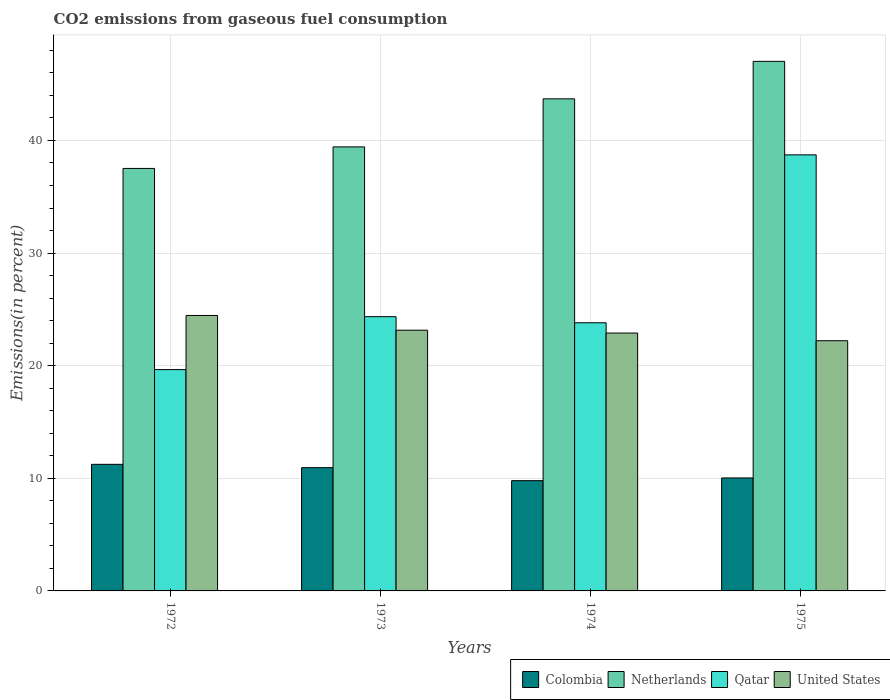How many different coloured bars are there?
Your response must be concise. 4. How many groups of bars are there?
Your answer should be compact. 4. Are the number of bars on each tick of the X-axis equal?
Provide a short and direct response. Yes. How many bars are there on the 1st tick from the left?
Your answer should be very brief. 4. How many bars are there on the 3rd tick from the right?
Provide a succinct answer. 4. In how many cases, is the number of bars for a given year not equal to the number of legend labels?
Provide a succinct answer. 0. What is the total CO2 emitted in Qatar in 1973?
Your response must be concise. 24.35. Across all years, what is the maximum total CO2 emitted in United States?
Keep it short and to the point. 24.46. Across all years, what is the minimum total CO2 emitted in Colombia?
Provide a succinct answer. 9.79. What is the total total CO2 emitted in Colombia in the graph?
Make the answer very short. 42.01. What is the difference between the total CO2 emitted in Colombia in 1973 and that in 1974?
Provide a short and direct response. 1.16. What is the difference between the total CO2 emitted in Qatar in 1973 and the total CO2 emitted in Colombia in 1974?
Offer a terse response. 14.56. What is the average total CO2 emitted in Netherlands per year?
Offer a very short reply. 41.92. In the year 1975, what is the difference between the total CO2 emitted in Netherlands and total CO2 emitted in Qatar?
Your answer should be compact. 8.3. In how many years, is the total CO2 emitted in United States greater than 16 %?
Offer a very short reply. 4. What is the ratio of the total CO2 emitted in Netherlands in 1972 to that in 1973?
Keep it short and to the point. 0.95. Is the difference between the total CO2 emitted in Netherlands in 1972 and 1973 greater than the difference between the total CO2 emitted in Qatar in 1972 and 1973?
Your response must be concise. Yes. What is the difference between the highest and the second highest total CO2 emitted in Colombia?
Your answer should be very brief. 0.29. What is the difference between the highest and the lowest total CO2 emitted in Netherlands?
Ensure brevity in your answer.  9.51. Is it the case that in every year, the sum of the total CO2 emitted in Qatar and total CO2 emitted in United States is greater than the sum of total CO2 emitted in Colombia and total CO2 emitted in Netherlands?
Provide a succinct answer. Yes. What does the 4th bar from the right in 1975 represents?
Provide a succinct answer. Colombia. How many bars are there?
Offer a very short reply. 16. What is the difference between two consecutive major ticks on the Y-axis?
Give a very brief answer. 10. Are the values on the major ticks of Y-axis written in scientific E-notation?
Your response must be concise. No. Does the graph contain grids?
Your answer should be compact. Yes. How many legend labels are there?
Make the answer very short. 4. How are the legend labels stacked?
Your answer should be very brief. Horizontal. What is the title of the graph?
Offer a terse response. CO2 emissions from gaseous fuel consumption. What is the label or title of the Y-axis?
Your response must be concise. Emissions(in percent). What is the Emissions(in percent) of Colombia in 1972?
Keep it short and to the point. 11.24. What is the Emissions(in percent) of Netherlands in 1972?
Provide a short and direct response. 37.52. What is the Emissions(in percent) in Qatar in 1972?
Your answer should be very brief. 19.65. What is the Emissions(in percent) in United States in 1972?
Your answer should be compact. 24.46. What is the Emissions(in percent) of Colombia in 1973?
Your answer should be compact. 10.95. What is the Emissions(in percent) in Netherlands in 1973?
Offer a very short reply. 39.43. What is the Emissions(in percent) in Qatar in 1973?
Your answer should be very brief. 24.35. What is the Emissions(in percent) of United States in 1973?
Ensure brevity in your answer.  23.15. What is the Emissions(in percent) of Colombia in 1974?
Your answer should be compact. 9.79. What is the Emissions(in percent) of Netherlands in 1974?
Ensure brevity in your answer.  43.7. What is the Emissions(in percent) of Qatar in 1974?
Make the answer very short. 23.81. What is the Emissions(in percent) of United States in 1974?
Your answer should be very brief. 22.9. What is the Emissions(in percent) of Colombia in 1975?
Make the answer very short. 10.03. What is the Emissions(in percent) in Netherlands in 1975?
Your response must be concise. 47.02. What is the Emissions(in percent) of Qatar in 1975?
Give a very brief answer. 38.72. What is the Emissions(in percent) of United States in 1975?
Your answer should be compact. 22.22. Across all years, what is the maximum Emissions(in percent) in Colombia?
Ensure brevity in your answer.  11.24. Across all years, what is the maximum Emissions(in percent) in Netherlands?
Your response must be concise. 47.02. Across all years, what is the maximum Emissions(in percent) in Qatar?
Give a very brief answer. 38.72. Across all years, what is the maximum Emissions(in percent) in United States?
Give a very brief answer. 24.46. Across all years, what is the minimum Emissions(in percent) in Colombia?
Provide a short and direct response. 9.79. Across all years, what is the minimum Emissions(in percent) of Netherlands?
Your answer should be very brief. 37.52. Across all years, what is the minimum Emissions(in percent) of Qatar?
Your answer should be very brief. 19.65. Across all years, what is the minimum Emissions(in percent) in United States?
Offer a very short reply. 22.22. What is the total Emissions(in percent) in Colombia in the graph?
Offer a terse response. 42.01. What is the total Emissions(in percent) of Netherlands in the graph?
Provide a short and direct response. 167.67. What is the total Emissions(in percent) in Qatar in the graph?
Your answer should be very brief. 106.54. What is the total Emissions(in percent) in United States in the graph?
Your response must be concise. 92.73. What is the difference between the Emissions(in percent) of Colombia in 1972 and that in 1973?
Make the answer very short. 0.29. What is the difference between the Emissions(in percent) of Netherlands in 1972 and that in 1973?
Your answer should be very brief. -1.91. What is the difference between the Emissions(in percent) of Qatar in 1972 and that in 1973?
Give a very brief answer. -4.7. What is the difference between the Emissions(in percent) in United States in 1972 and that in 1973?
Your response must be concise. 1.31. What is the difference between the Emissions(in percent) of Colombia in 1972 and that in 1974?
Ensure brevity in your answer.  1.45. What is the difference between the Emissions(in percent) in Netherlands in 1972 and that in 1974?
Your answer should be very brief. -6.18. What is the difference between the Emissions(in percent) of Qatar in 1972 and that in 1974?
Provide a succinct answer. -4.16. What is the difference between the Emissions(in percent) of United States in 1972 and that in 1974?
Give a very brief answer. 1.56. What is the difference between the Emissions(in percent) of Colombia in 1972 and that in 1975?
Keep it short and to the point. 1.21. What is the difference between the Emissions(in percent) in Netherlands in 1972 and that in 1975?
Offer a terse response. -9.51. What is the difference between the Emissions(in percent) of Qatar in 1972 and that in 1975?
Ensure brevity in your answer.  -19.07. What is the difference between the Emissions(in percent) in United States in 1972 and that in 1975?
Your answer should be compact. 2.24. What is the difference between the Emissions(in percent) in Colombia in 1973 and that in 1974?
Provide a short and direct response. 1.16. What is the difference between the Emissions(in percent) of Netherlands in 1973 and that in 1974?
Your answer should be very brief. -4.27. What is the difference between the Emissions(in percent) in Qatar in 1973 and that in 1974?
Offer a very short reply. 0.54. What is the difference between the Emissions(in percent) in United States in 1973 and that in 1974?
Keep it short and to the point. 0.25. What is the difference between the Emissions(in percent) of Colombia in 1973 and that in 1975?
Ensure brevity in your answer.  0.92. What is the difference between the Emissions(in percent) in Netherlands in 1973 and that in 1975?
Make the answer very short. -7.6. What is the difference between the Emissions(in percent) in Qatar in 1973 and that in 1975?
Your response must be concise. -14.37. What is the difference between the Emissions(in percent) of United States in 1973 and that in 1975?
Offer a terse response. 0.94. What is the difference between the Emissions(in percent) in Colombia in 1974 and that in 1975?
Your response must be concise. -0.24. What is the difference between the Emissions(in percent) of Netherlands in 1974 and that in 1975?
Provide a short and direct response. -3.33. What is the difference between the Emissions(in percent) in Qatar in 1974 and that in 1975?
Ensure brevity in your answer.  -14.91. What is the difference between the Emissions(in percent) of United States in 1974 and that in 1975?
Keep it short and to the point. 0.68. What is the difference between the Emissions(in percent) in Colombia in 1972 and the Emissions(in percent) in Netherlands in 1973?
Your response must be concise. -28.19. What is the difference between the Emissions(in percent) in Colombia in 1972 and the Emissions(in percent) in Qatar in 1973?
Your answer should be compact. -13.11. What is the difference between the Emissions(in percent) of Colombia in 1972 and the Emissions(in percent) of United States in 1973?
Give a very brief answer. -11.91. What is the difference between the Emissions(in percent) in Netherlands in 1972 and the Emissions(in percent) in Qatar in 1973?
Your response must be concise. 13.16. What is the difference between the Emissions(in percent) of Netherlands in 1972 and the Emissions(in percent) of United States in 1973?
Ensure brevity in your answer.  14.37. What is the difference between the Emissions(in percent) of Qatar in 1972 and the Emissions(in percent) of United States in 1973?
Your response must be concise. -3.5. What is the difference between the Emissions(in percent) in Colombia in 1972 and the Emissions(in percent) in Netherlands in 1974?
Offer a terse response. -32.46. What is the difference between the Emissions(in percent) of Colombia in 1972 and the Emissions(in percent) of Qatar in 1974?
Offer a terse response. -12.57. What is the difference between the Emissions(in percent) of Colombia in 1972 and the Emissions(in percent) of United States in 1974?
Make the answer very short. -11.66. What is the difference between the Emissions(in percent) in Netherlands in 1972 and the Emissions(in percent) in Qatar in 1974?
Offer a terse response. 13.71. What is the difference between the Emissions(in percent) of Netherlands in 1972 and the Emissions(in percent) of United States in 1974?
Keep it short and to the point. 14.62. What is the difference between the Emissions(in percent) of Qatar in 1972 and the Emissions(in percent) of United States in 1974?
Your answer should be very brief. -3.25. What is the difference between the Emissions(in percent) of Colombia in 1972 and the Emissions(in percent) of Netherlands in 1975?
Provide a succinct answer. -35.78. What is the difference between the Emissions(in percent) of Colombia in 1972 and the Emissions(in percent) of Qatar in 1975?
Offer a very short reply. -27.48. What is the difference between the Emissions(in percent) in Colombia in 1972 and the Emissions(in percent) in United States in 1975?
Provide a succinct answer. -10.98. What is the difference between the Emissions(in percent) in Netherlands in 1972 and the Emissions(in percent) in Qatar in 1975?
Make the answer very short. -1.2. What is the difference between the Emissions(in percent) in Netherlands in 1972 and the Emissions(in percent) in United States in 1975?
Your answer should be compact. 15.3. What is the difference between the Emissions(in percent) of Qatar in 1972 and the Emissions(in percent) of United States in 1975?
Keep it short and to the point. -2.56. What is the difference between the Emissions(in percent) of Colombia in 1973 and the Emissions(in percent) of Netherlands in 1974?
Your response must be concise. -32.75. What is the difference between the Emissions(in percent) of Colombia in 1973 and the Emissions(in percent) of Qatar in 1974?
Your answer should be compact. -12.86. What is the difference between the Emissions(in percent) in Colombia in 1973 and the Emissions(in percent) in United States in 1974?
Make the answer very short. -11.95. What is the difference between the Emissions(in percent) in Netherlands in 1973 and the Emissions(in percent) in Qatar in 1974?
Your response must be concise. 15.62. What is the difference between the Emissions(in percent) of Netherlands in 1973 and the Emissions(in percent) of United States in 1974?
Offer a very short reply. 16.53. What is the difference between the Emissions(in percent) of Qatar in 1973 and the Emissions(in percent) of United States in 1974?
Your response must be concise. 1.45. What is the difference between the Emissions(in percent) in Colombia in 1973 and the Emissions(in percent) in Netherlands in 1975?
Your answer should be compact. -36.08. What is the difference between the Emissions(in percent) in Colombia in 1973 and the Emissions(in percent) in Qatar in 1975?
Keep it short and to the point. -27.77. What is the difference between the Emissions(in percent) of Colombia in 1973 and the Emissions(in percent) of United States in 1975?
Your answer should be compact. -11.27. What is the difference between the Emissions(in percent) of Netherlands in 1973 and the Emissions(in percent) of Qatar in 1975?
Offer a terse response. 0.71. What is the difference between the Emissions(in percent) of Netherlands in 1973 and the Emissions(in percent) of United States in 1975?
Provide a short and direct response. 17.21. What is the difference between the Emissions(in percent) in Qatar in 1973 and the Emissions(in percent) in United States in 1975?
Keep it short and to the point. 2.14. What is the difference between the Emissions(in percent) of Colombia in 1974 and the Emissions(in percent) of Netherlands in 1975?
Make the answer very short. -37.23. What is the difference between the Emissions(in percent) in Colombia in 1974 and the Emissions(in percent) in Qatar in 1975?
Keep it short and to the point. -28.93. What is the difference between the Emissions(in percent) in Colombia in 1974 and the Emissions(in percent) in United States in 1975?
Provide a succinct answer. -12.43. What is the difference between the Emissions(in percent) of Netherlands in 1974 and the Emissions(in percent) of Qatar in 1975?
Give a very brief answer. 4.97. What is the difference between the Emissions(in percent) of Netherlands in 1974 and the Emissions(in percent) of United States in 1975?
Ensure brevity in your answer.  21.48. What is the difference between the Emissions(in percent) of Qatar in 1974 and the Emissions(in percent) of United States in 1975?
Give a very brief answer. 1.59. What is the average Emissions(in percent) of Colombia per year?
Offer a very short reply. 10.5. What is the average Emissions(in percent) of Netherlands per year?
Your answer should be very brief. 41.92. What is the average Emissions(in percent) of Qatar per year?
Provide a succinct answer. 26.63. What is the average Emissions(in percent) in United States per year?
Keep it short and to the point. 23.18. In the year 1972, what is the difference between the Emissions(in percent) in Colombia and Emissions(in percent) in Netherlands?
Keep it short and to the point. -26.28. In the year 1972, what is the difference between the Emissions(in percent) of Colombia and Emissions(in percent) of Qatar?
Provide a succinct answer. -8.41. In the year 1972, what is the difference between the Emissions(in percent) in Colombia and Emissions(in percent) in United States?
Keep it short and to the point. -13.22. In the year 1972, what is the difference between the Emissions(in percent) of Netherlands and Emissions(in percent) of Qatar?
Provide a succinct answer. 17.86. In the year 1972, what is the difference between the Emissions(in percent) in Netherlands and Emissions(in percent) in United States?
Provide a succinct answer. 13.06. In the year 1972, what is the difference between the Emissions(in percent) in Qatar and Emissions(in percent) in United States?
Offer a terse response. -4.81. In the year 1973, what is the difference between the Emissions(in percent) of Colombia and Emissions(in percent) of Netherlands?
Offer a very short reply. -28.48. In the year 1973, what is the difference between the Emissions(in percent) in Colombia and Emissions(in percent) in Qatar?
Give a very brief answer. -13.41. In the year 1973, what is the difference between the Emissions(in percent) of Colombia and Emissions(in percent) of United States?
Your response must be concise. -12.21. In the year 1973, what is the difference between the Emissions(in percent) in Netherlands and Emissions(in percent) in Qatar?
Offer a terse response. 15.08. In the year 1973, what is the difference between the Emissions(in percent) in Netherlands and Emissions(in percent) in United States?
Your response must be concise. 16.28. In the year 1973, what is the difference between the Emissions(in percent) in Qatar and Emissions(in percent) in United States?
Offer a terse response. 1.2. In the year 1974, what is the difference between the Emissions(in percent) of Colombia and Emissions(in percent) of Netherlands?
Make the answer very short. -33.91. In the year 1974, what is the difference between the Emissions(in percent) in Colombia and Emissions(in percent) in Qatar?
Make the answer very short. -14.02. In the year 1974, what is the difference between the Emissions(in percent) of Colombia and Emissions(in percent) of United States?
Your answer should be very brief. -13.11. In the year 1974, what is the difference between the Emissions(in percent) of Netherlands and Emissions(in percent) of Qatar?
Make the answer very short. 19.89. In the year 1974, what is the difference between the Emissions(in percent) in Netherlands and Emissions(in percent) in United States?
Provide a succinct answer. 20.8. In the year 1974, what is the difference between the Emissions(in percent) in Qatar and Emissions(in percent) in United States?
Your answer should be very brief. 0.91. In the year 1975, what is the difference between the Emissions(in percent) in Colombia and Emissions(in percent) in Netherlands?
Offer a very short reply. -36.99. In the year 1975, what is the difference between the Emissions(in percent) in Colombia and Emissions(in percent) in Qatar?
Your answer should be compact. -28.69. In the year 1975, what is the difference between the Emissions(in percent) in Colombia and Emissions(in percent) in United States?
Keep it short and to the point. -12.18. In the year 1975, what is the difference between the Emissions(in percent) of Netherlands and Emissions(in percent) of Qatar?
Offer a terse response. 8.3. In the year 1975, what is the difference between the Emissions(in percent) in Netherlands and Emissions(in percent) in United States?
Ensure brevity in your answer.  24.81. In the year 1975, what is the difference between the Emissions(in percent) of Qatar and Emissions(in percent) of United States?
Your answer should be compact. 16.51. What is the ratio of the Emissions(in percent) in Colombia in 1972 to that in 1973?
Offer a terse response. 1.03. What is the ratio of the Emissions(in percent) in Netherlands in 1972 to that in 1973?
Make the answer very short. 0.95. What is the ratio of the Emissions(in percent) of Qatar in 1972 to that in 1973?
Your answer should be compact. 0.81. What is the ratio of the Emissions(in percent) in United States in 1972 to that in 1973?
Offer a very short reply. 1.06. What is the ratio of the Emissions(in percent) of Colombia in 1972 to that in 1974?
Ensure brevity in your answer.  1.15. What is the ratio of the Emissions(in percent) in Netherlands in 1972 to that in 1974?
Your answer should be compact. 0.86. What is the ratio of the Emissions(in percent) in Qatar in 1972 to that in 1974?
Your response must be concise. 0.83. What is the ratio of the Emissions(in percent) in United States in 1972 to that in 1974?
Your answer should be very brief. 1.07. What is the ratio of the Emissions(in percent) in Colombia in 1972 to that in 1975?
Offer a very short reply. 1.12. What is the ratio of the Emissions(in percent) of Netherlands in 1972 to that in 1975?
Keep it short and to the point. 0.8. What is the ratio of the Emissions(in percent) of Qatar in 1972 to that in 1975?
Give a very brief answer. 0.51. What is the ratio of the Emissions(in percent) in United States in 1972 to that in 1975?
Ensure brevity in your answer.  1.1. What is the ratio of the Emissions(in percent) in Colombia in 1973 to that in 1974?
Provide a short and direct response. 1.12. What is the ratio of the Emissions(in percent) in Netherlands in 1973 to that in 1974?
Give a very brief answer. 0.9. What is the ratio of the Emissions(in percent) in Qatar in 1973 to that in 1974?
Provide a short and direct response. 1.02. What is the ratio of the Emissions(in percent) of United States in 1973 to that in 1974?
Your response must be concise. 1.01. What is the ratio of the Emissions(in percent) of Colombia in 1973 to that in 1975?
Your response must be concise. 1.09. What is the ratio of the Emissions(in percent) in Netherlands in 1973 to that in 1975?
Keep it short and to the point. 0.84. What is the ratio of the Emissions(in percent) of Qatar in 1973 to that in 1975?
Keep it short and to the point. 0.63. What is the ratio of the Emissions(in percent) in United States in 1973 to that in 1975?
Provide a short and direct response. 1.04. What is the ratio of the Emissions(in percent) of Netherlands in 1974 to that in 1975?
Ensure brevity in your answer.  0.93. What is the ratio of the Emissions(in percent) of Qatar in 1974 to that in 1975?
Provide a short and direct response. 0.61. What is the ratio of the Emissions(in percent) in United States in 1974 to that in 1975?
Your answer should be compact. 1.03. What is the difference between the highest and the second highest Emissions(in percent) of Colombia?
Make the answer very short. 0.29. What is the difference between the highest and the second highest Emissions(in percent) in Netherlands?
Offer a terse response. 3.33. What is the difference between the highest and the second highest Emissions(in percent) of Qatar?
Make the answer very short. 14.37. What is the difference between the highest and the second highest Emissions(in percent) of United States?
Give a very brief answer. 1.31. What is the difference between the highest and the lowest Emissions(in percent) in Colombia?
Your answer should be very brief. 1.45. What is the difference between the highest and the lowest Emissions(in percent) of Netherlands?
Your answer should be compact. 9.51. What is the difference between the highest and the lowest Emissions(in percent) in Qatar?
Provide a succinct answer. 19.07. What is the difference between the highest and the lowest Emissions(in percent) of United States?
Ensure brevity in your answer.  2.24. 